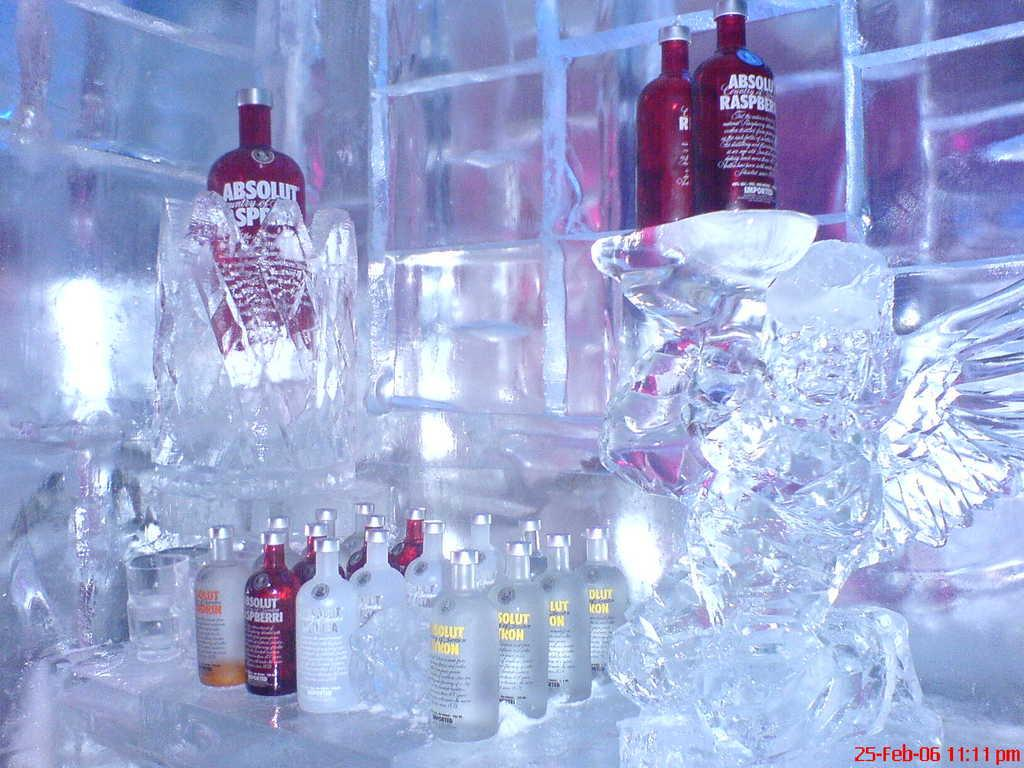What is the main subject of the image? The main subject of the image is many bottles. Can you describe the bottles in the image? There are many bottles in the image. What is located near the bottles? There is an ice present near the bottles. What type of scissors can be seen cutting the smoke in the image? There is no smoke or scissors present in the image. What is the learning process of the bottles in the image? The bottles are inanimate objects and do not have a learning process. 